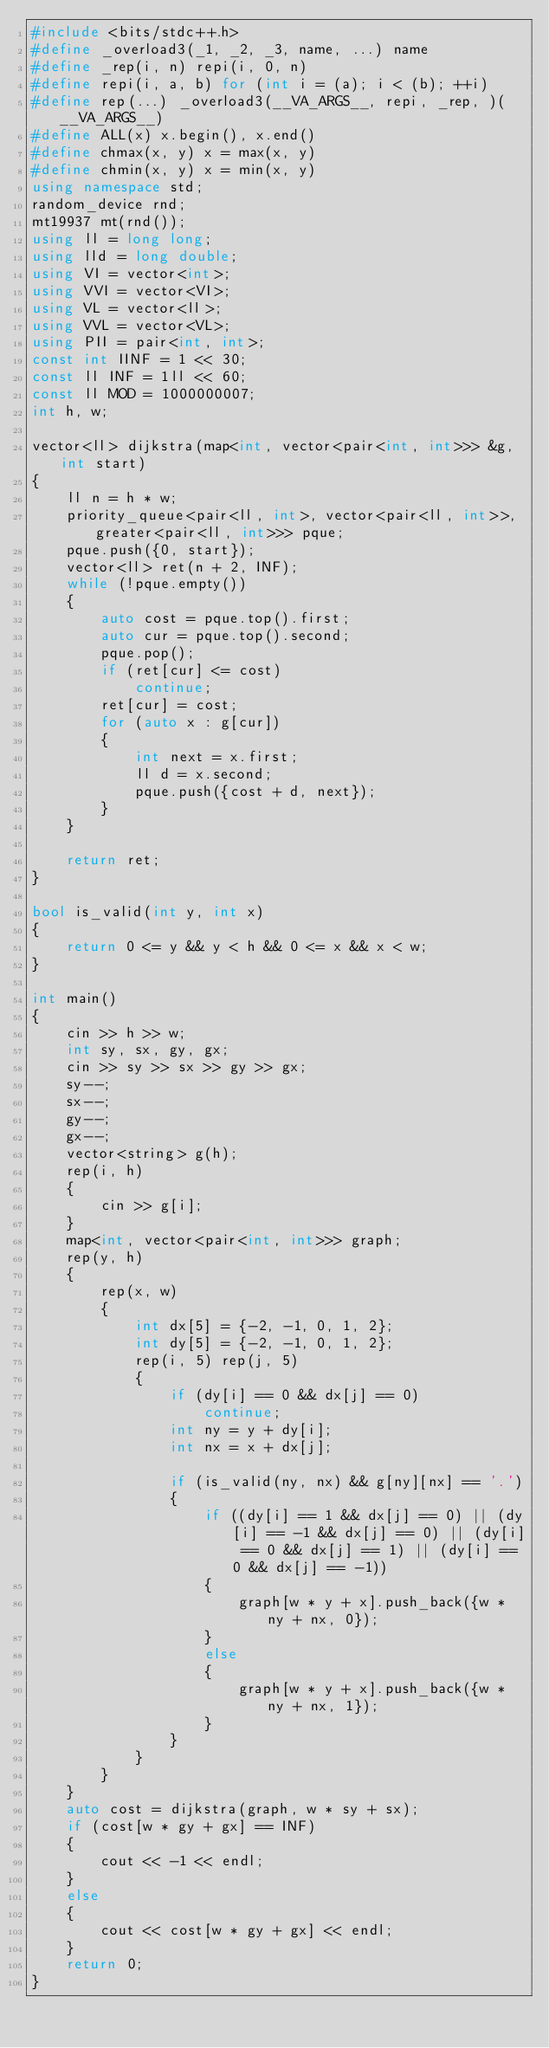<code> <loc_0><loc_0><loc_500><loc_500><_C++_>#include <bits/stdc++.h>
#define _overload3(_1, _2, _3, name, ...) name
#define _rep(i, n) repi(i, 0, n)
#define repi(i, a, b) for (int i = (a); i < (b); ++i)
#define rep(...) _overload3(__VA_ARGS__, repi, _rep, )(__VA_ARGS__)
#define ALL(x) x.begin(), x.end()
#define chmax(x, y) x = max(x, y)
#define chmin(x, y) x = min(x, y)
using namespace std;
random_device rnd;
mt19937 mt(rnd());
using ll = long long;
using lld = long double;
using VI = vector<int>;
using VVI = vector<VI>;
using VL = vector<ll>;
using VVL = vector<VL>;
using PII = pair<int, int>;
const int IINF = 1 << 30;
const ll INF = 1ll << 60;
const ll MOD = 1000000007;
int h, w;

vector<ll> dijkstra(map<int, vector<pair<int, int>>> &g, int start)
{
    ll n = h * w;
    priority_queue<pair<ll, int>, vector<pair<ll, int>>, greater<pair<ll, int>>> pque;
    pque.push({0, start});
    vector<ll> ret(n + 2, INF);
    while (!pque.empty())
    {
        auto cost = pque.top().first;
        auto cur = pque.top().second;
        pque.pop();
        if (ret[cur] <= cost)
            continue;
        ret[cur] = cost;
        for (auto x : g[cur])
        {
            int next = x.first;
            ll d = x.second;
            pque.push({cost + d, next});
        }
    }

    return ret;
}

bool is_valid(int y, int x)
{
    return 0 <= y && y < h && 0 <= x && x < w;
}

int main()
{
    cin >> h >> w;
    int sy, sx, gy, gx;
    cin >> sy >> sx >> gy >> gx;
    sy--;
    sx--;
    gy--;
    gx--;
    vector<string> g(h);
    rep(i, h)
    {
        cin >> g[i];
    }
    map<int, vector<pair<int, int>>> graph;
    rep(y, h)
    {
        rep(x, w)
        {
            int dx[5] = {-2, -1, 0, 1, 2};
            int dy[5] = {-2, -1, 0, 1, 2};
            rep(i, 5) rep(j, 5)
            {
                if (dy[i] == 0 && dx[j] == 0)
                    continue;
                int ny = y + dy[i];
                int nx = x + dx[j];

                if (is_valid(ny, nx) && g[ny][nx] == '.')
                {
                    if ((dy[i] == 1 && dx[j] == 0) || (dy[i] == -1 && dx[j] == 0) || (dy[i] == 0 && dx[j] == 1) || (dy[i] == 0 && dx[j] == -1))
                    {
                        graph[w * y + x].push_back({w * ny + nx, 0});
                    }
                    else
                    {
                        graph[w * y + x].push_back({w * ny + nx, 1});
                    }
                }
            }
        }
    }
    auto cost = dijkstra(graph, w * sy + sx);
    if (cost[w * gy + gx] == INF)
    {
        cout << -1 << endl;
    }
    else
    {
        cout << cost[w * gy + gx] << endl;
    }
    return 0;
}</code> 